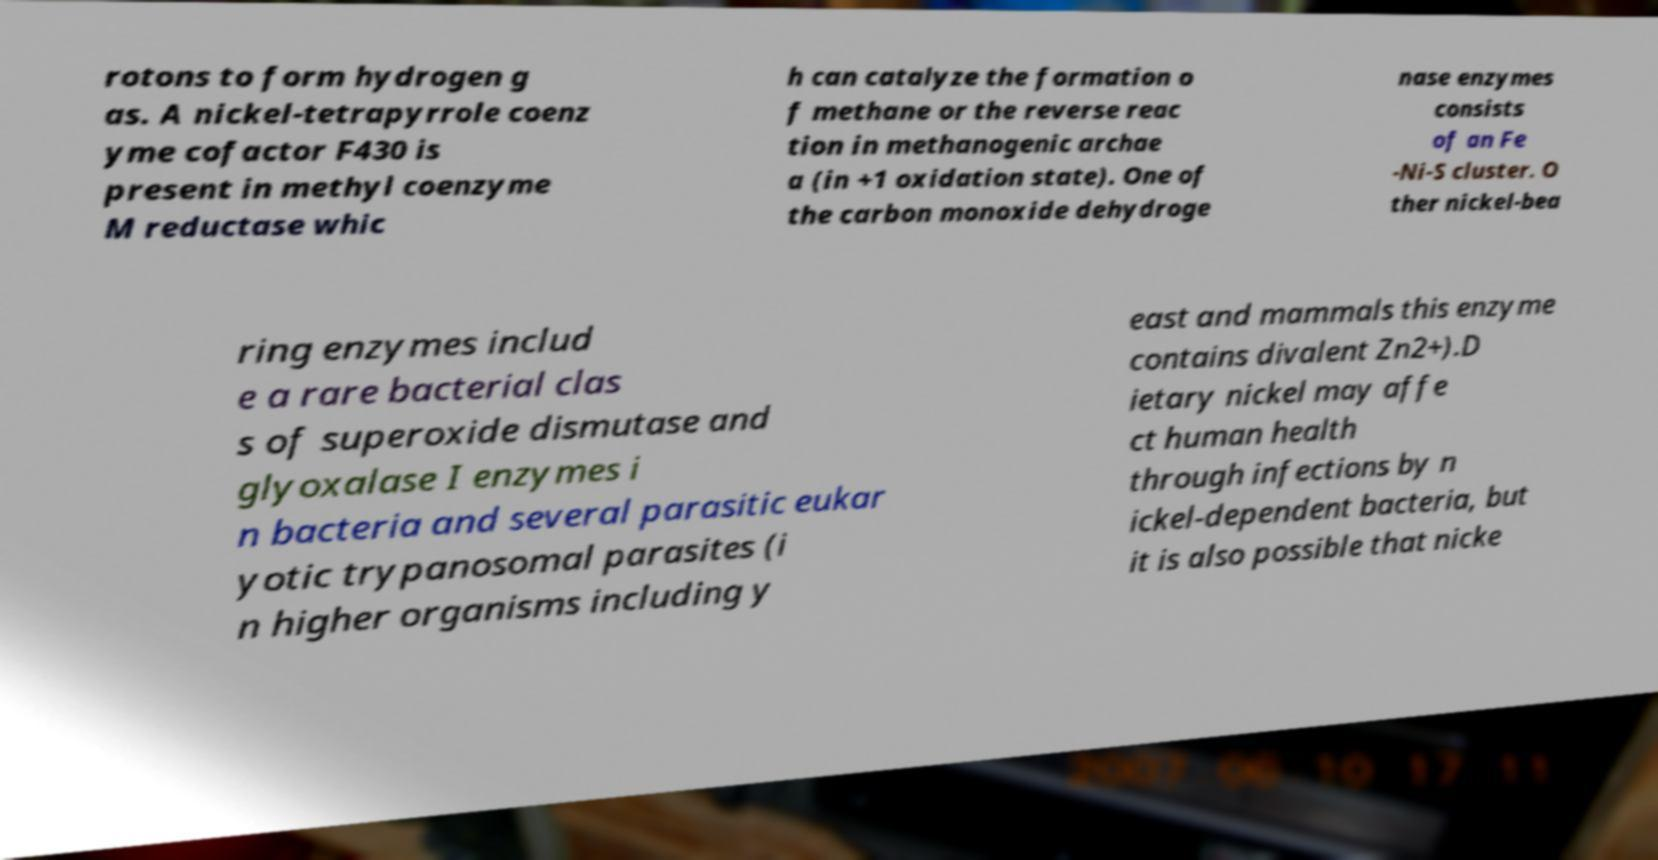For documentation purposes, I need the text within this image transcribed. Could you provide that? rotons to form hydrogen g as. A nickel-tetrapyrrole coenz yme cofactor F430 is present in methyl coenzyme M reductase whic h can catalyze the formation o f methane or the reverse reac tion in methanogenic archae a (in +1 oxidation state). One of the carbon monoxide dehydroge nase enzymes consists of an Fe -Ni-S cluster. O ther nickel-bea ring enzymes includ e a rare bacterial clas s of superoxide dismutase and glyoxalase I enzymes i n bacteria and several parasitic eukar yotic trypanosomal parasites (i n higher organisms including y east and mammals this enzyme contains divalent Zn2+).D ietary nickel may affe ct human health through infections by n ickel-dependent bacteria, but it is also possible that nicke 